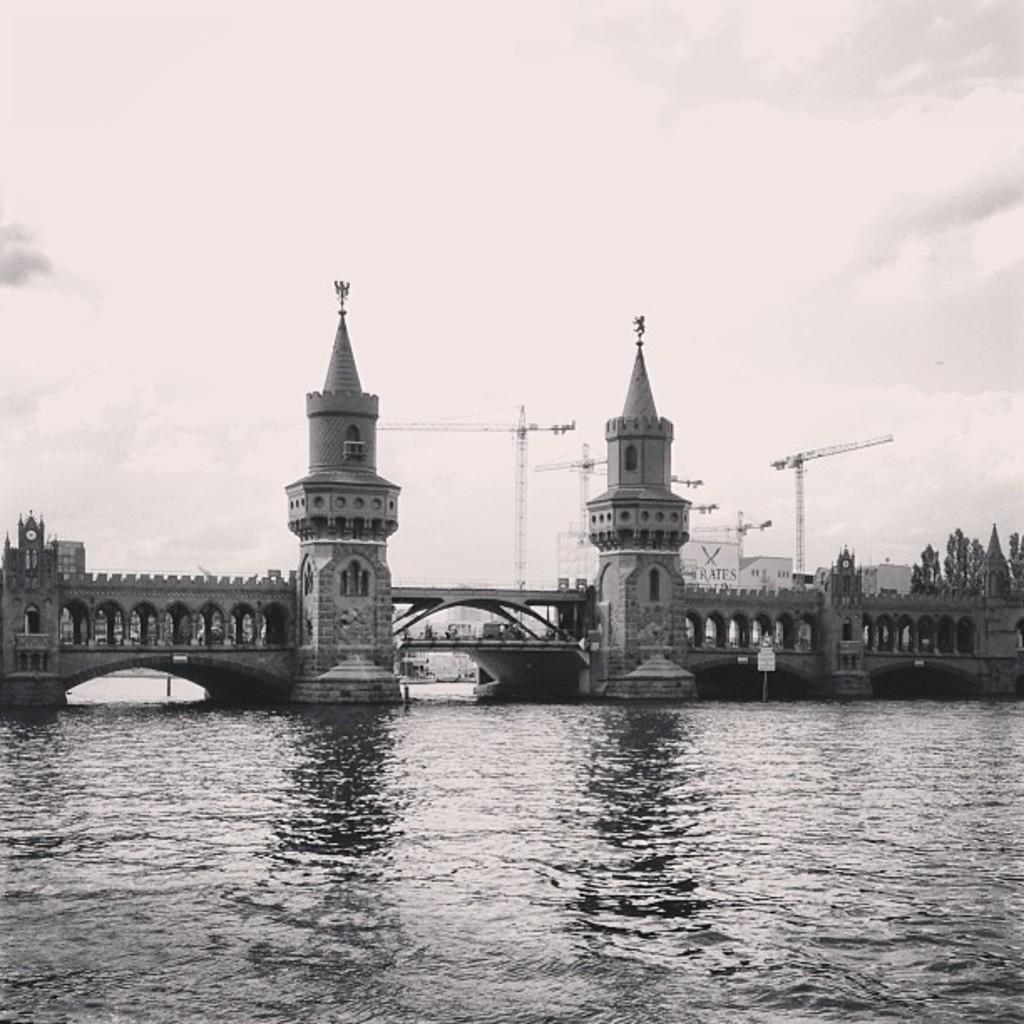Please provide a concise description of this image. In this image, we can see a bridge with walls and pillars. At the bottom, we can see the water. Here there are few trees, towers. Background there is a cloudy sky. 